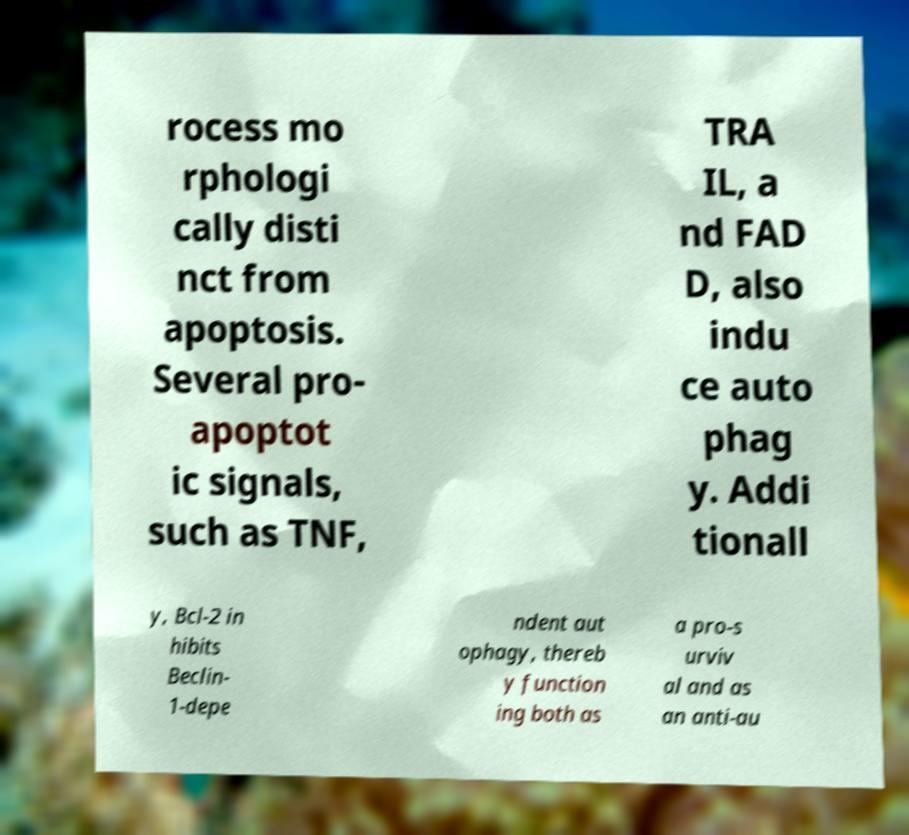Can you accurately transcribe the text from the provided image for me? rocess mo rphologi cally disti nct from apoptosis. Several pro- apoptot ic signals, such as TNF, TRA IL, a nd FAD D, also indu ce auto phag y. Addi tionall y, Bcl-2 in hibits Beclin- 1-depe ndent aut ophagy, thereb y function ing both as a pro-s urviv al and as an anti-au 